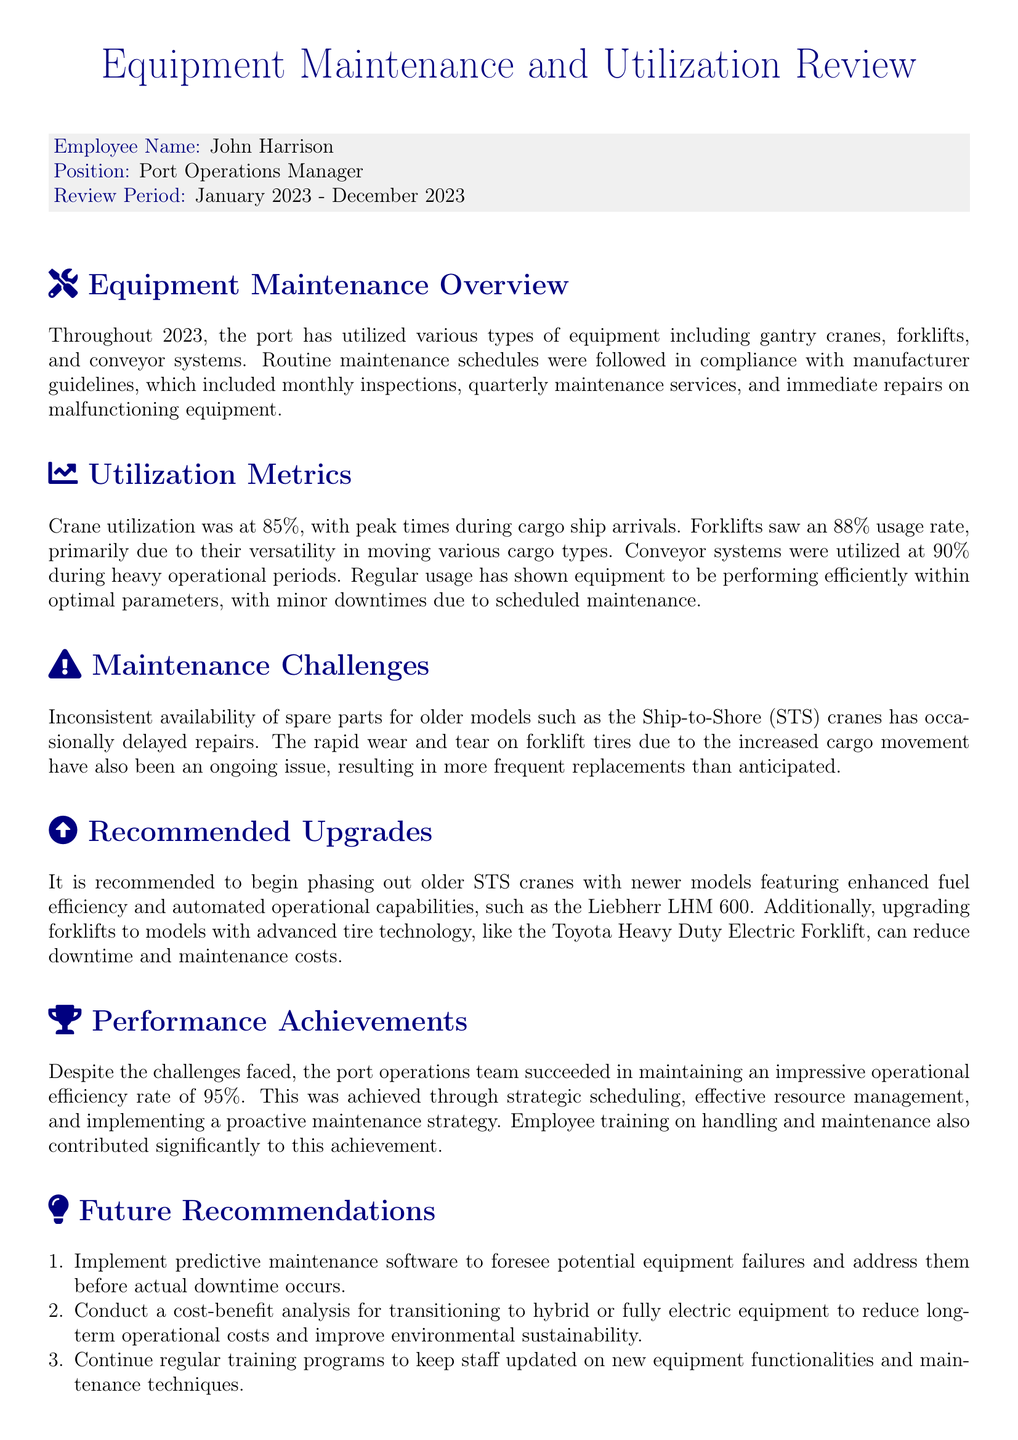what is the employee name? The employee name is mentioned at the beginning of the document under the employee details section.
Answer: John Harrison what is the position of the employee? The position is specified in the employee details section, indicating the role of the individual in the organization.
Answer: Port Operations Manager what was the review period? The review period indicates the timeframe being evaluated in the appraisal form and is explicitly stated.
Answer: January 2023 - December 2023 what is the utilization rate of cranes? The crane utilization rate is provided in the utilization metrics section, reflecting operational efficiency.
Answer: 85% what equipment is recommended for an upgrade? The document suggests specific equipment that requires replacements or upgrades in the recommendations section.
Answer: Liebherr LHM 600 what maintenance challenge is highlighted for older models? This question addresses the specific issues raised in the maintenance challenges section regarding older equipment.
Answer: Inconsistent availability of spare parts what percentage operational efficiency was achieved? The operational efficiency percentage is mentioned in the performance achievements section of the document.
Answer: 95% what type of maintenance software is recommended? This question asks about specific recommendations in the future recommendations section for improving maintenance management.
Answer: Predictive maintenance software how many recommendations are listed for future improvements? The count of recommendations is drawn from the future recommendations section, indicating areas for growth or enhancement.
Answer: 3 